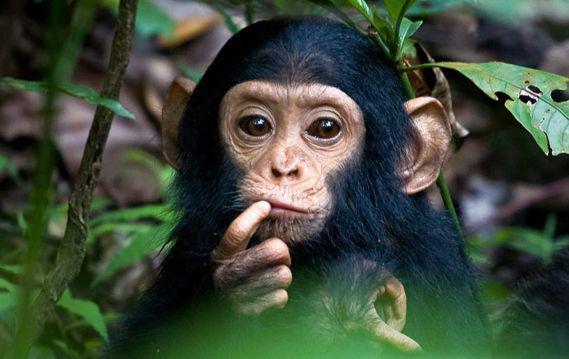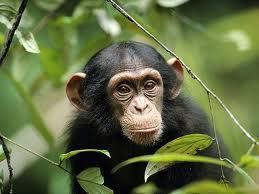The first image is the image on the left, the second image is the image on the right. For the images shown, is this caption "There's exactly two chimpanzees." true? Answer yes or no. Yes. 